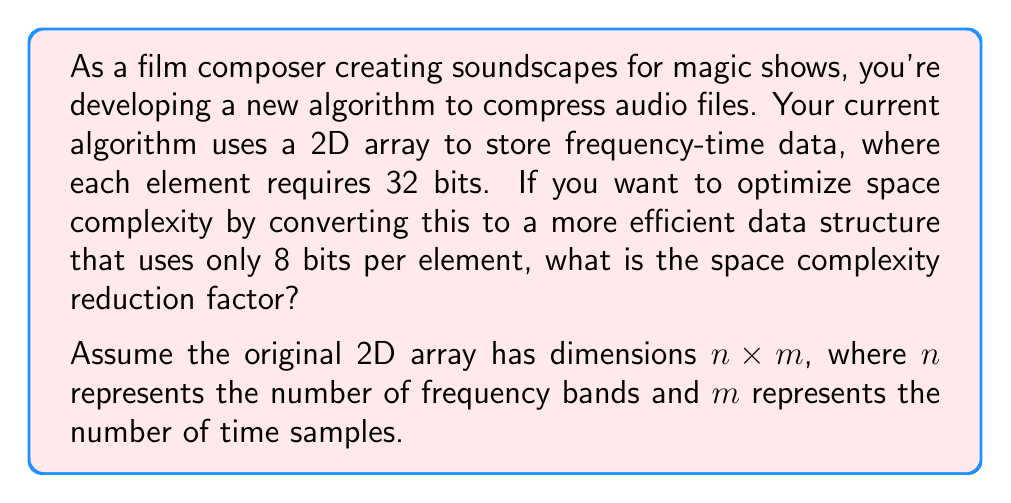Could you help me with this problem? To solve this problem, we need to compare the space requirements of the original data structure with the optimized one:

1. Original space requirement:
   - Each element uses 32 bits
   - Total elements: $n \times m$
   - Total space: $32 \times n \times m$ bits

2. Optimized space requirement:
   - Each element uses 8 bits
   - Total elements: $n \times m$
   - Total space: $8 \times n \times m$ bits

3. Calculate the reduction factor:
   Let's define the reduction factor as $r$, where:
   $$r = \frac{\text{Original space}}{\text{Optimized space}}$$

   Substituting the values:
   $$r = \frac{32 \times n \times m}{8 \times n \times m}$$

4. Simplify the equation:
   $$r = \frac{32}{8} = 4$$

Therefore, the space complexity reduction factor is 4, meaning the optimized data structure uses 1/4 of the original space.
Answer: The space complexity reduction factor is 4. 